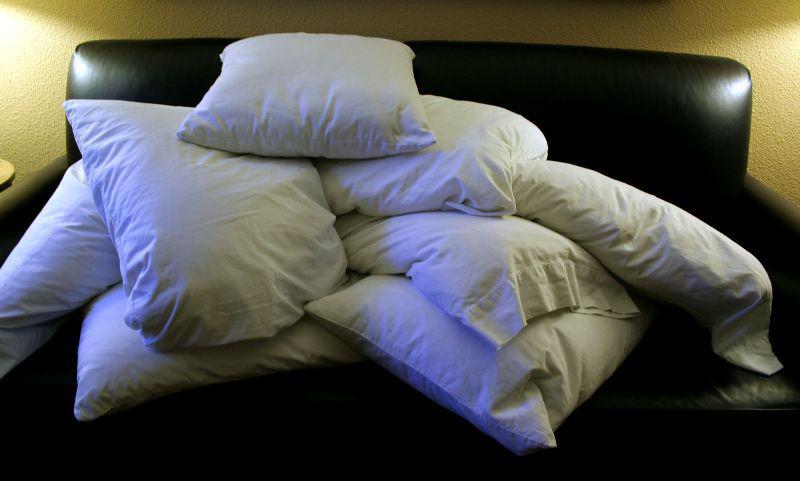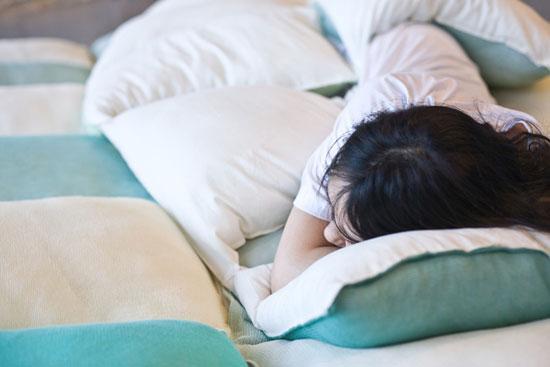The first image is the image on the left, the second image is the image on the right. For the images displayed, is the sentence "In one of the images there is just one person lying in bed with multiple pillows." factually correct? Answer yes or no. Yes. 